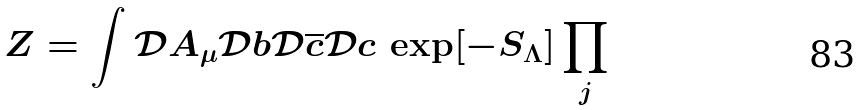<formula> <loc_0><loc_0><loc_500><loc_500>Z = \int \mathcal { D } A _ { \mu } \mathcal { D } b \mathcal { D } \overline { c } \mathcal { D } c \, \exp [ - S _ { \Lambda } ] \prod _ { j }</formula> 